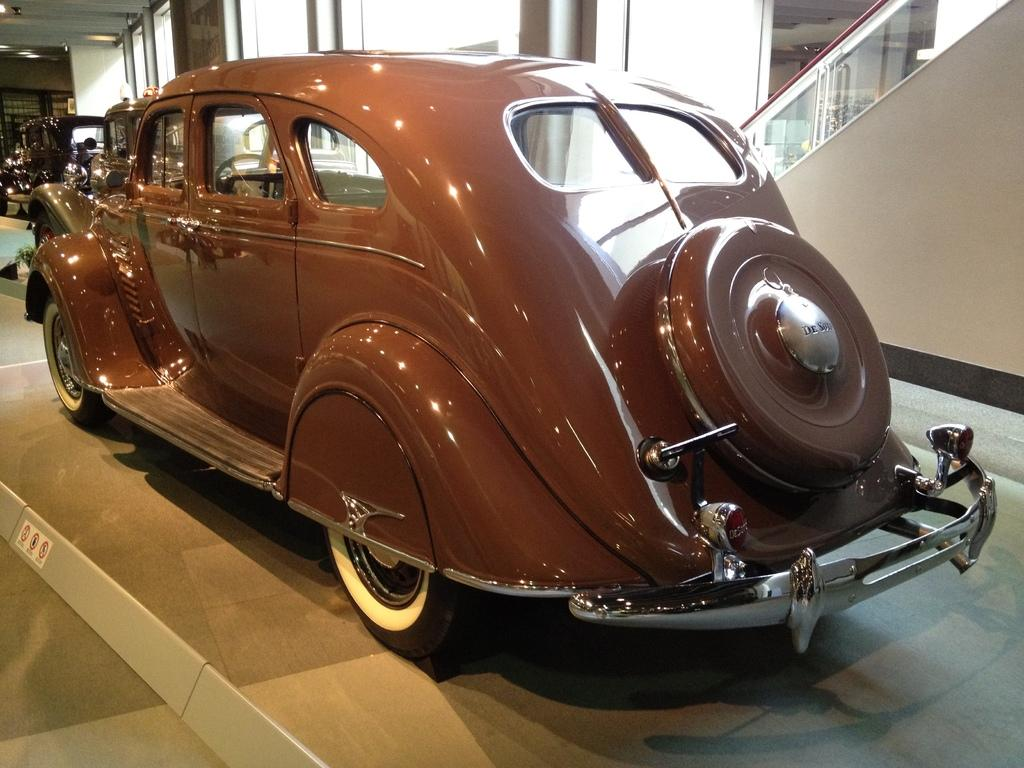What type of vehicles are in the image? There are antique cars in the image. What is the material of the door visible in the image? The door is made of glass. Can you determine the location of the image based on the facts? The image was likely taken inside a building, as there is a wall visible. How does the wind affect the antique cars in the image? There is no wind present in the image, as it was likely taken inside a building. What type of downtown area is visible in the image? There is no downtown area present in the image; it features antique cars and a glass door inside a building. 